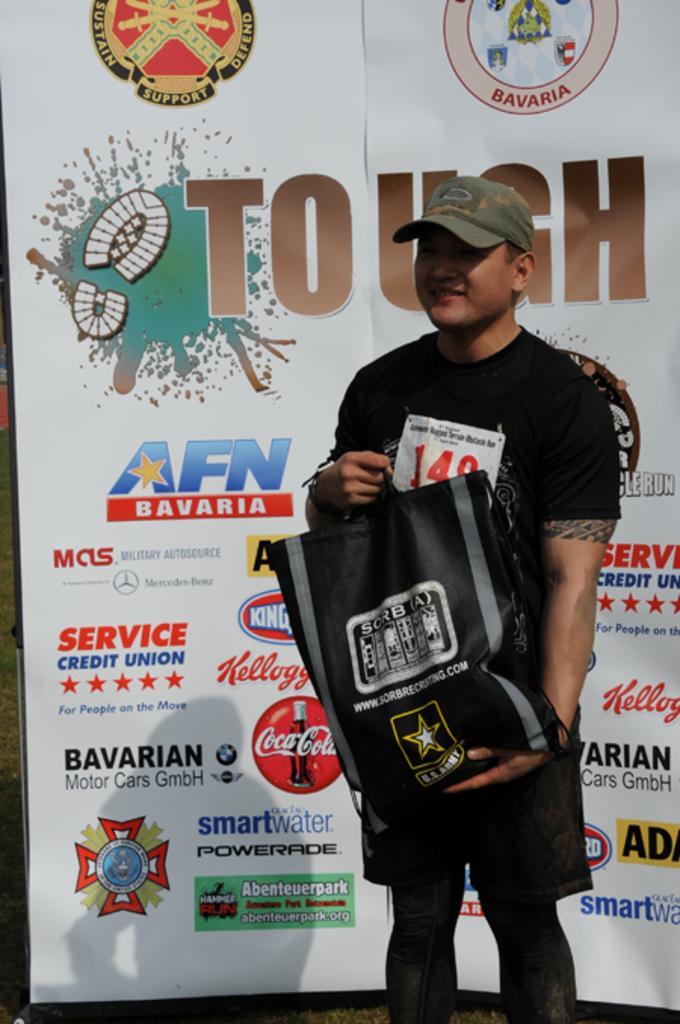Please provide a concise description of this image. In this image there is a person holding a bag and wearing a cap, there is a poster with some text and few logo symbols. 